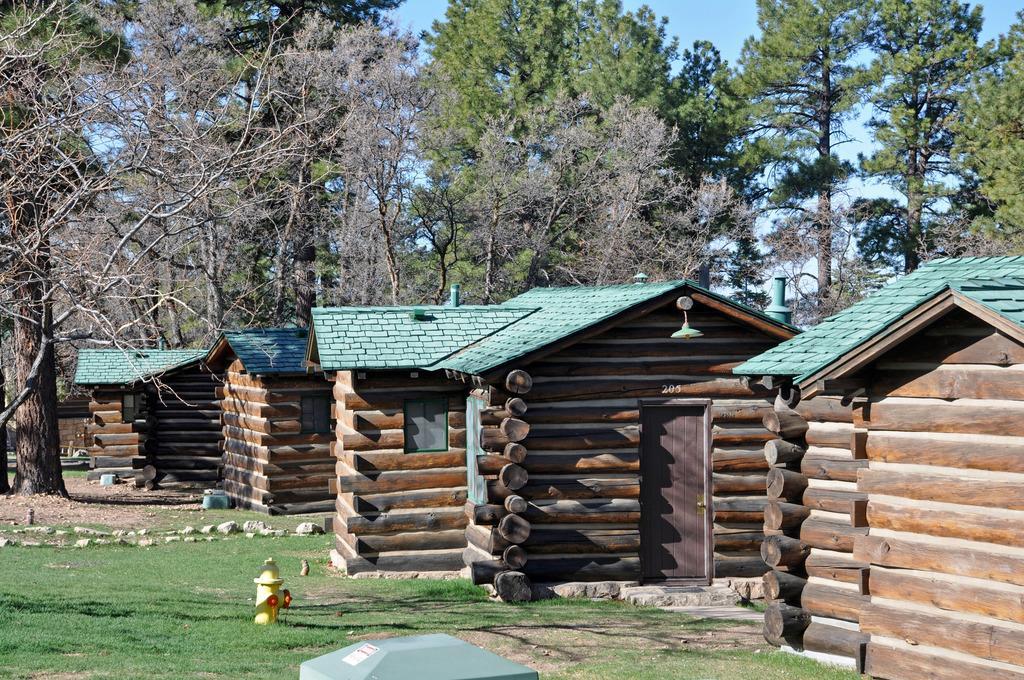Could you give a brief overview of what you see in this image? In the middle of the image there are some sheds. At the top of the image there are some trees. Behind the trees there are some clouds and sky. At the bottom of the image there is grass. 